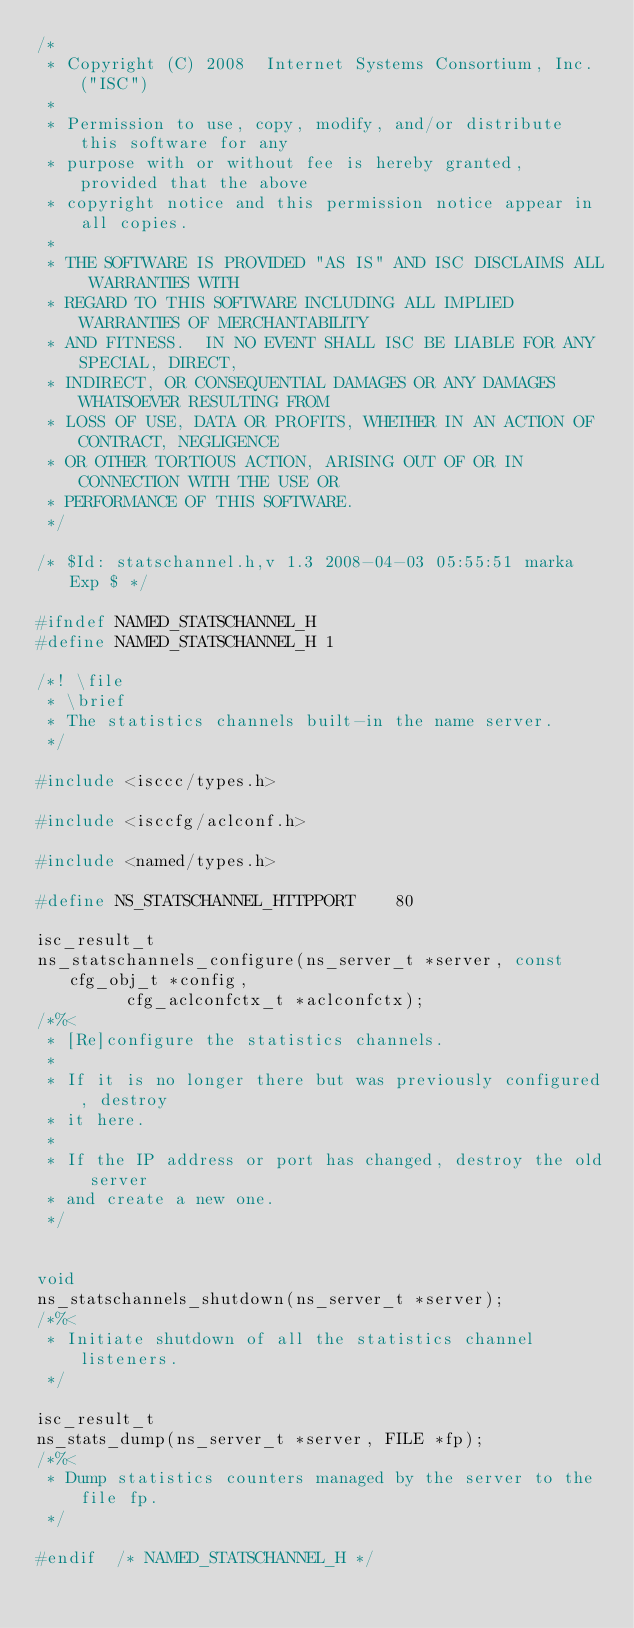<code> <loc_0><loc_0><loc_500><loc_500><_C_>/*
 * Copyright (C) 2008  Internet Systems Consortium, Inc. ("ISC")
 *
 * Permission to use, copy, modify, and/or distribute this software for any
 * purpose with or without fee is hereby granted, provided that the above
 * copyright notice and this permission notice appear in all copies.
 *
 * THE SOFTWARE IS PROVIDED "AS IS" AND ISC DISCLAIMS ALL WARRANTIES WITH
 * REGARD TO THIS SOFTWARE INCLUDING ALL IMPLIED WARRANTIES OF MERCHANTABILITY
 * AND FITNESS.  IN NO EVENT SHALL ISC BE LIABLE FOR ANY SPECIAL, DIRECT,
 * INDIRECT, OR CONSEQUENTIAL DAMAGES OR ANY DAMAGES WHATSOEVER RESULTING FROM
 * LOSS OF USE, DATA OR PROFITS, WHETHER IN AN ACTION OF CONTRACT, NEGLIGENCE
 * OR OTHER TORTIOUS ACTION, ARISING OUT OF OR IN CONNECTION WITH THE USE OR
 * PERFORMANCE OF THIS SOFTWARE.
 */

/* $Id: statschannel.h,v 1.3 2008-04-03 05:55:51 marka Exp $ */

#ifndef NAMED_STATSCHANNEL_H
#define NAMED_STATSCHANNEL_H 1

/*! \file
 * \brief
 * The statistics channels built-in the name server.
 */

#include <isccc/types.h>

#include <isccfg/aclconf.h>

#include <named/types.h>

#define NS_STATSCHANNEL_HTTPPORT		80

isc_result_t
ns_statschannels_configure(ns_server_t *server, const cfg_obj_t *config,
			   cfg_aclconfctx_t *aclconfctx);
/*%<
 * [Re]configure the statistics channels.
 *
 * If it is no longer there but was previously configured, destroy
 * it here.
 *
 * If the IP address or port has changed, destroy the old server
 * and create a new one.
 */


void
ns_statschannels_shutdown(ns_server_t *server);
/*%<
 * Initiate shutdown of all the statistics channel listeners.
 */

isc_result_t
ns_stats_dump(ns_server_t *server, FILE *fp);
/*%<
 * Dump statistics counters managed by the server to the file fp.
 */

#endif	/* NAMED_STATSCHANNEL_H */
</code> 